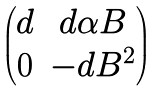<formula> <loc_0><loc_0><loc_500><loc_500>\begin{pmatrix} d & d \alpha B \\ 0 & - d B ^ { 2 } \end{pmatrix}</formula> 